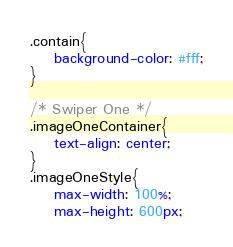Convert code to text. <code><loc_0><loc_0><loc_500><loc_500><_CSS_>.contain{
    background-color: #fff;
}

/* Swiper One */
.imageOneContainer{
    text-align: center;
}
.imageOneStyle{
    max-width: 100%;
    max-height: 600px;</code> 